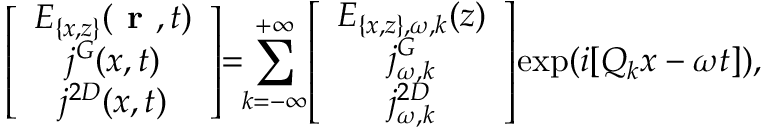Convert formula to latex. <formula><loc_0><loc_0><loc_500><loc_500>\left [ \begin{array} { c } { E _ { \{ x , z \} } ( r , t ) } \\ { j ^ { G } ( x , t ) } \\ { j ^ { 2 D } ( x , t ) } \end{array} \right ] \, = \, \sum _ { k = - \infty } ^ { + \infty } \, \left [ \begin{array} { c } { E _ { \{ x , z \} , \omega , k } ( z ) } \\ { j _ { \omega , k } ^ { G } } \\ { j _ { \omega , k } ^ { 2 D } } \end{array} \right ] \, \exp ( i [ Q _ { k } x - \omega t ] ) ,</formula> 